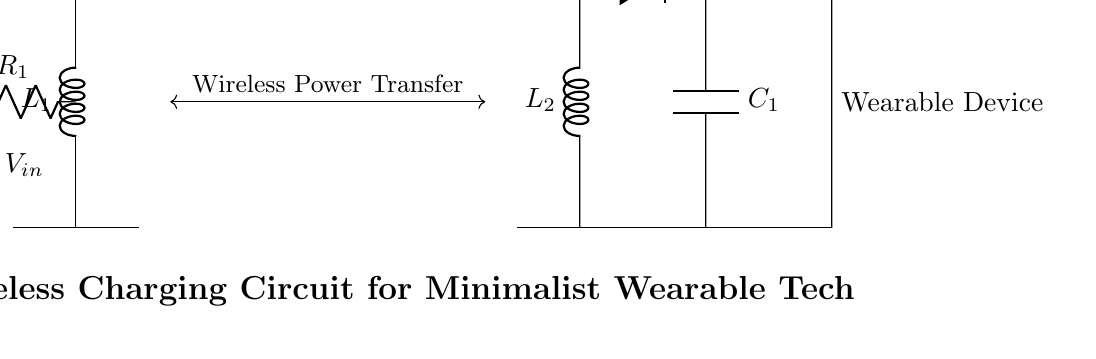What is the input voltage of the transmitter? The input voltage is represented by \( V_{in} \) and is shown at the left side of the circuit connected to the transmitter.
Answer: \( V_{in} \) What components are involved in the transmission of power? The power transmission involves the transmitter coil, represented by L1, alongside the resistor R1 and the input voltage \( V_{in} \).
Answer: L1, R1, \( V_{in} \) What type of load does the receiver circuit have? The load in the receiver circuit is specified as \( R_{load} \), which indicates it is a resistive load connected at the output.
Answer: \( R_{load} \) How many inductors are present in this circuit? The circuit contains two inductors, L1 in the transmitter and L2 in the receiver, which are key for wireless power transfer.
Answer: 2 What is the role of the diode in the receiver circuit? The diode \( D_1 \) in the circuit ensures that current flows in only one direction, allowing for rectification of the AC voltage induced by the receiver coil.
Answer: Rectification What is the current flowing through the load? The current flowing through the load is noted as \( I_{out} \) in the circuit, indicating the output current delivered to the wearable device.
Answer: \( I_{out} \) What do the arrows between the transmitter and receiver indicate? The arrows represent wireless power transfer between the transmitter and receiver coils, signifying the operation of inductive coupling.
Answer: Wireless Power Transfer 